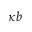Convert formula to latex. <formula><loc_0><loc_0><loc_500><loc_500>\kappa b</formula> 